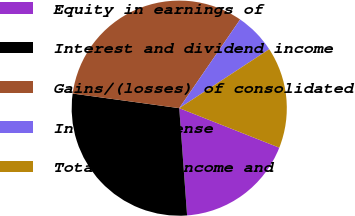<chart> <loc_0><loc_0><loc_500><loc_500><pie_chart><fcel>Equity in earnings of<fcel>Interest and dividend income<fcel>Gains/(losses) of consolidated<fcel>Interest expense<fcel>Total other income and<nl><fcel>17.85%<fcel>28.33%<fcel>32.41%<fcel>6.19%<fcel>15.22%<nl></chart> 